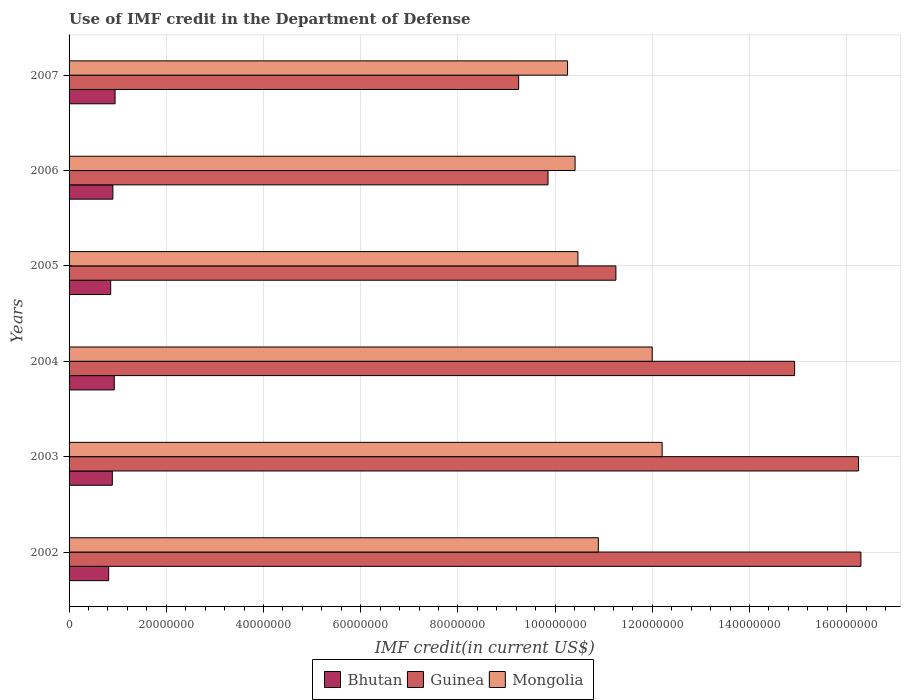How many groups of bars are there?
Ensure brevity in your answer.  6. Are the number of bars on each tick of the Y-axis equal?
Your answer should be compact. Yes. How many bars are there on the 4th tick from the bottom?
Your answer should be compact. 3. What is the label of the 5th group of bars from the top?
Provide a short and direct response. 2003. What is the IMF credit in the Department of Defense in Mongolia in 2004?
Provide a succinct answer. 1.20e+08. Across all years, what is the maximum IMF credit in the Department of Defense in Mongolia?
Offer a very short reply. 1.22e+08. Across all years, what is the minimum IMF credit in the Department of Defense in Guinea?
Offer a terse response. 9.25e+07. What is the total IMF credit in the Department of Defense in Guinea in the graph?
Provide a succinct answer. 7.78e+08. What is the difference between the IMF credit in the Department of Defense in Bhutan in 2003 and that in 2005?
Your response must be concise. 3.39e+05. What is the difference between the IMF credit in the Department of Defense in Bhutan in 2006 and the IMF credit in the Department of Defense in Mongolia in 2005?
Provide a succinct answer. -9.57e+07. What is the average IMF credit in the Department of Defense in Mongolia per year?
Ensure brevity in your answer.  1.10e+08. In the year 2004, what is the difference between the IMF credit in the Department of Defense in Guinea and IMF credit in the Department of Defense in Bhutan?
Offer a very short reply. 1.40e+08. In how many years, is the IMF credit in the Department of Defense in Bhutan greater than 124000000 US$?
Your answer should be very brief. 0. What is the ratio of the IMF credit in the Department of Defense in Mongolia in 2003 to that in 2006?
Provide a succinct answer. 1.17. Is the difference between the IMF credit in the Department of Defense in Guinea in 2006 and 2007 greater than the difference between the IMF credit in the Department of Defense in Bhutan in 2006 and 2007?
Provide a short and direct response. Yes. What is the difference between the highest and the second highest IMF credit in the Department of Defense in Bhutan?
Give a very brief answer. 1.63e+05. What is the difference between the highest and the lowest IMF credit in the Department of Defense in Bhutan?
Your answer should be compact. 1.32e+06. Is the sum of the IMF credit in the Department of Defense in Mongolia in 2003 and 2007 greater than the maximum IMF credit in the Department of Defense in Bhutan across all years?
Your response must be concise. Yes. What does the 2nd bar from the top in 2005 represents?
Give a very brief answer. Guinea. What does the 1st bar from the bottom in 2005 represents?
Offer a terse response. Bhutan. How many bars are there?
Give a very brief answer. 18. Are all the bars in the graph horizontal?
Ensure brevity in your answer.  Yes. How many years are there in the graph?
Provide a short and direct response. 6. What is the difference between two consecutive major ticks on the X-axis?
Offer a terse response. 2.00e+07. Does the graph contain any zero values?
Give a very brief answer. No. Where does the legend appear in the graph?
Offer a terse response. Bottom center. How are the legend labels stacked?
Provide a succinct answer. Horizontal. What is the title of the graph?
Ensure brevity in your answer.  Use of IMF credit in the Department of Defense. Does "Sweden" appear as one of the legend labels in the graph?
Keep it short and to the point. No. What is the label or title of the X-axis?
Make the answer very short. IMF credit(in current US$). What is the IMF credit(in current US$) in Bhutan in 2002?
Give a very brief answer. 8.14e+06. What is the IMF credit(in current US$) of Guinea in 2002?
Provide a succinct answer. 1.63e+08. What is the IMF credit(in current US$) in Mongolia in 2002?
Your answer should be compact. 1.09e+08. What is the IMF credit(in current US$) in Bhutan in 2003?
Provide a succinct answer. 8.90e+06. What is the IMF credit(in current US$) of Guinea in 2003?
Make the answer very short. 1.62e+08. What is the IMF credit(in current US$) of Mongolia in 2003?
Offer a very short reply. 1.22e+08. What is the IMF credit(in current US$) in Bhutan in 2004?
Offer a terse response. 9.30e+06. What is the IMF credit(in current US$) in Guinea in 2004?
Your answer should be very brief. 1.49e+08. What is the IMF credit(in current US$) of Mongolia in 2004?
Offer a very short reply. 1.20e+08. What is the IMF credit(in current US$) of Bhutan in 2005?
Offer a very short reply. 8.56e+06. What is the IMF credit(in current US$) in Guinea in 2005?
Offer a very short reply. 1.13e+08. What is the IMF credit(in current US$) in Mongolia in 2005?
Offer a very short reply. 1.05e+08. What is the IMF credit(in current US$) of Bhutan in 2006?
Your answer should be very brief. 9.01e+06. What is the IMF credit(in current US$) of Guinea in 2006?
Your response must be concise. 9.85e+07. What is the IMF credit(in current US$) of Mongolia in 2006?
Ensure brevity in your answer.  1.04e+08. What is the IMF credit(in current US$) in Bhutan in 2007?
Your answer should be very brief. 9.46e+06. What is the IMF credit(in current US$) of Guinea in 2007?
Ensure brevity in your answer.  9.25e+07. What is the IMF credit(in current US$) of Mongolia in 2007?
Provide a succinct answer. 1.03e+08. Across all years, what is the maximum IMF credit(in current US$) in Bhutan?
Offer a very short reply. 9.46e+06. Across all years, what is the maximum IMF credit(in current US$) in Guinea?
Provide a short and direct response. 1.63e+08. Across all years, what is the maximum IMF credit(in current US$) of Mongolia?
Your answer should be very brief. 1.22e+08. Across all years, what is the minimum IMF credit(in current US$) of Bhutan?
Make the answer very short. 8.14e+06. Across all years, what is the minimum IMF credit(in current US$) of Guinea?
Provide a succinct answer. 9.25e+07. Across all years, what is the minimum IMF credit(in current US$) of Mongolia?
Give a very brief answer. 1.03e+08. What is the total IMF credit(in current US$) in Bhutan in the graph?
Provide a short and direct response. 5.34e+07. What is the total IMF credit(in current US$) of Guinea in the graph?
Give a very brief answer. 7.78e+08. What is the total IMF credit(in current US$) of Mongolia in the graph?
Your answer should be compact. 6.62e+08. What is the difference between the IMF credit(in current US$) of Bhutan in 2002 and that in 2003?
Your answer should be very brief. -7.57e+05. What is the difference between the IMF credit(in current US$) in Guinea in 2002 and that in 2003?
Make the answer very short. 4.97e+05. What is the difference between the IMF credit(in current US$) of Mongolia in 2002 and that in 2003?
Offer a terse response. -1.31e+07. What is the difference between the IMF credit(in current US$) in Bhutan in 2002 and that in 2004?
Provide a short and direct response. -1.16e+06. What is the difference between the IMF credit(in current US$) of Guinea in 2002 and that in 2004?
Provide a succinct answer. 1.36e+07. What is the difference between the IMF credit(in current US$) in Mongolia in 2002 and that in 2004?
Your answer should be very brief. -1.11e+07. What is the difference between the IMF credit(in current US$) of Bhutan in 2002 and that in 2005?
Ensure brevity in your answer.  -4.18e+05. What is the difference between the IMF credit(in current US$) in Guinea in 2002 and that in 2005?
Keep it short and to the point. 5.04e+07. What is the difference between the IMF credit(in current US$) in Mongolia in 2002 and that in 2005?
Your answer should be very brief. 4.20e+06. What is the difference between the IMF credit(in current US$) in Bhutan in 2002 and that in 2006?
Make the answer very short. -8.68e+05. What is the difference between the IMF credit(in current US$) of Guinea in 2002 and that in 2006?
Provide a succinct answer. 6.44e+07. What is the difference between the IMF credit(in current US$) of Mongolia in 2002 and that in 2006?
Your answer should be compact. 4.78e+06. What is the difference between the IMF credit(in current US$) of Bhutan in 2002 and that in 2007?
Your answer should be very brief. -1.32e+06. What is the difference between the IMF credit(in current US$) of Guinea in 2002 and that in 2007?
Your answer should be very brief. 7.04e+07. What is the difference between the IMF credit(in current US$) in Mongolia in 2002 and that in 2007?
Offer a terse response. 6.33e+06. What is the difference between the IMF credit(in current US$) in Bhutan in 2003 and that in 2004?
Provide a succinct answer. -4.02e+05. What is the difference between the IMF credit(in current US$) of Guinea in 2003 and that in 2004?
Make the answer very short. 1.31e+07. What is the difference between the IMF credit(in current US$) in Mongolia in 2003 and that in 2004?
Ensure brevity in your answer.  2.04e+06. What is the difference between the IMF credit(in current US$) of Bhutan in 2003 and that in 2005?
Provide a short and direct response. 3.39e+05. What is the difference between the IMF credit(in current US$) of Guinea in 2003 and that in 2005?
Give a very brief answer. 4.99e+07. What is the difference between the IMF credit(in current US$) of Mongolia in 2003 and that in 2005?
Provide a short and direct response. 1.73e+07. What is the difference between the IMF credit(in current US$) in Bhutan in 2003 and that in 2006?
Make the answer very short. -1.11e+05. What is the difference between the IMF credit(in current US$) in Guinea in 2003 and that in 2006?
Offer a very short reply. 6.39e+07. What is the difference between the IMF credit(in current US$) of Mongolia in 2003 and that in 2006?
Provide a succinct answer. 1.79e+07. What is the difference between the IMF credit(in current US$) of Bhutan in 2003 and that in 2007?
Your answer should be compact. -5.65e+05. What is the difference between the IMF credit(in current US$) of Guinea in 2003 and that in 2007?
Offer a very short reply. 6.99e+07. What is the difference between the IMF credit(in current US$) of Mongolia in 2003 and that in 2007?
Your answer should be very brief. 1.95e+07. What is the difference between the IMF credit(in current US$) in Bhutan in 2004 and that in 2005?
Give a very brief answer. 7.41e+05. What is the difference between the IMF credit(in current US$) in Guinea in 2004 and that in 2005?
Offer a very short reply. 3.68e+07. What is the difference between the IMF credit(in current US$) of Mongolia in 2004 and that in 2005?
Your answer should be very brief. 1.53e+07. What is the difference between the IMF credit(in current US$) in Bhutan in 2004 and that in 2006?
Your response must be concise. 2.91e+05. What is the difference between the IMF credit(in current US$) in Guinea in 2004 and that in 2006?
Provide a succinct answer. 5.07e+07. What is the difference between the IMF credit(in current US$) of Mongolia in 2004 and that in 2006?
Make the answer very short. 1.59e+07. What is the difference between the IMF credit(in current US$) in Bhutan in 2004 and that in 2007?
Offer a very short reply. -1.63e+05. What is the difference between the IMF credit(in current US$) in Guinea in 2004 and that in 2007?
Your response must be concise. 5.68e+07. What is the difference between the IMF credit(in current US$) of Mongolia in 2004 and that in 2007?
Make the answer very short. 1.74e+07. What is the difference between the IMF credit(in current US$) of Bhutan in 2005 and that in 2006?
Ensure brevity in your answer.  -4.50e+05. What is the difference between the IMF credit(in current US$) of Guinea in 2005 and that in 2006?
Keep it short and to the point. 1.40e+07. What is the difference between the IMF credit(in current US$) of Mongolia in 2005 and that in 2006?
Give a very brief answer. 5.81e+05. What is the difference between the IMF credit(in current US$) in Bhutan in 2005 and that in 2007?
Your response must be concise. -9.04e+05. What is the difference between the IMF credit(in current US$) of Guinea in 2005 and that in 2007?
Your answer should be very brief. 2.00e+07. What is the difference between the IMF credit(in current US$) of Mongolia in 2005 and that in 2007?
Provide a succinct answer. 2.13e+06. What is the difference between the IMF credit(in current US$) of Bhutan in 2006 and that in 2007?
Keep it short and to the point. -4.54e+05. What is the difference between the IMF credit(in current US$) in Guinea in 2006 and that in 2007?
Keep it short and to the point. 6.04e+06. What is the difference between the IMF credit(in current US$) in Mongolia in 2006 and that in 2007?
Make the answer very short. 1.55e+06. What is the difference between the IMF credit(in current US$) in Bhutan in 2002 and the IMF credit(in current US$) in Guinea in 2003?
Offer a very short reply. -1.54e+08. What is the difference between the IMF credit(in current US$) in Bhutan in 2002 and the IMF credit(in current US$) in Mongolia in 2003?
Your response must be concise. -1.14e+08. What is the difference between the IMF credit(in current US$) in Guinea in 2002 and the IMF credit(in current US$) in Mongolia in 2003?
Make the answer very short. 4.09e+07. What is the difference between the IMF credit(in current US$) in Bhutan in 2002 and the IMF credit(in current US$) in Guinea in 2004?
Your answer should be very brief. -1.41e+08. What is the difference between the IMF credit(in current US$) of Bhutan in 2002 and the IMF credit(in current US$) of Mongolia in 2004?
Offer a terse response. -1.12e+08. What is the difference between the IMF credit(in current US$) in Guinea in 2002 and the IMF credit(in current US$) in Mongolia in 2004?
Give a very brief answer. 4.29e+07. What is the difference between the IMF credit(in current US$) of Bhutan in 2002 and the IMF credit(in current US$) of Guinea in 2005?
Provide a short and direct response. -1.04e+08. What is the difference between the IMF credit(in current US$) of Bhutan in 2002 and the IMF credit(in current US$) of Mongolia in 2005?
Provide a succinct answer. -9.65e+07. What is the difference between the IMF credit(in current US$) in Guinea in 2002 and the IMF credit(in current US$) in Mongolia in 2005?
Provide a succinct answer. 5.82e+07. What is the difference between the IMF credit(in current US$) of Bhutan in 2002 and the IMF credit(in current US$) of Guinea in 2006?
Offer a terse response. -9.04e+07. What is the difference between the IMF credit(in current US$) of Bhutan in 2002 and the IMF credit(in current US$) of Mongolia in 2006?
Keep it short and to the point. -9.60e+07. What is the difference between the IMF credit(in current US$) in Guinea in 2002 and the IMF credit(in current US$) in Mongolia in 2006?
Give a very brief answer. 5.88e+07. What is the difference between the IMF credit(in current US$) in Bhutan in 2002 and the IMF credit(in current US$) in Guinea in 2007?
Make the answer very short. -8.44e+07. What is the difference between the IMF credit(in current US$) in Bhutan in 2002 and the IMF credit(in current US$) in Mongolia in 2007?
Your answer should be compact. -9.44e+07. What is the difference between the IMF credit(in current US$) of Guinea in 2002 and the IMF credit(in current US$) of Mongolia in 2007?
Your answer should be very brief. 6.04e+07. What is the difference between the IMF credit(in current US$) in Bhutan in 2003 and the IMF credit(in current US$) in Guinea in 2004?
Your answer should be very brief. -1.40e+08. What is the difference between the IMF credit(in current US$) of Bhutan in 2003 and the IMF credit(in current US$) of Mongolia in 2004?
Keep it short and to the point. -1.11e+08. What is the difference between the IMF credit(in current US$) of Guinea in 2003 and the IMF credit(in current US$) of Mongolia in 2004?
Your answer should be compact. 4.24e+07. What is the difference between the IMF credit(in current US$) of Bhutan in 2003 and the IMF credit(in current US$) of Guinea in 2005?
Keep it short and to the point. -1.04e+08. What is the difference between the IMF credit(in current US$) of Bhutan in 2003 and the IMF credit(in current US$) of Mongolia in 2005?
Offer a very short reply. -9.58e+07. What is the difference between the IMF credit(in current US$) in Guinea in 2003 and the IMF credit(in current US$) in Mongolia in 2005?
Keep it short and to the point. 5.77e+07. What is the difference between the IMF credit(in current US$) of Bhutan in 2003 and the IMF credit(in current US$) of Guinea in 2006?
Your response must be concise. -8.96e+07. What is the difference between the IMF credit(in current US$) of Bhutan in 2003 and the IMF credit(in current US$) of Mongolia in 2006?
Your answer should be compact. -9.52e+07. What is the difference between the IMF credit(in current US$) in Guinea in 2003 and the IMF credit(in current US$) in Mongolia in 2006?
Provide a succinct answer. 5.83e+07. What is the difference between the IMF credit(in current US$) of Bhutan in 2003 and the IMF credit(in current US$) of Guinea in 2007?
Keep it short and to the point. -8.36e+07. What is the difference between the IMF credit(in current US$) of Bhutan in 2003 and the IMF credit(in current US$) of Mongolia in 2007?
Offer a very short reply. -9.37e+07. What is the difference between the IMF credit(in current US$) of Guinea in 2003 and the IMF credit(in current US$) of Mongolia in 2007?
Ensure brevity in your answer.  5.99e+07. What is the difference between the IMF credit(in current US$) in Bhutan in 2004 and the IMF credit(in current US$) in Guinea in 2005?
Provide a short and direct response. -1.03e+08. What is the difference between the IMF credit(in current US$) of Bhutan in 2004 and the IMF credit(in current US$) of Mongolia in 2005?
Your answer should be very brief. -9.54e+07. What is the difference between the IMF credit(in current US$) in Guinea in 2004 and the IMF credit(in current US$) in Mongolia in 2005?
Offer a very short reply. 4.46e+07. What is the difference between the IMF credit(in current US$) in Bhutan in 2004 and the IMF credit(in current US$) in Guinea in 2006?
Ensure brevity in your answer.  -8.92e+07. What is the difference between the IMF credit(in current US$) in Bhutan in 2004 and the IMF credit(in current US$) in Mongolia in 2006?
Your response must be concise. -9.48e+07. What is the difference between the IMF credit(in current US$) in Guinea in 2004 and the IMF credit(in current US$) in Mongolia in 2006?
Make the answer very short. 4.52e+07. What is the difference between the IMF credit(in current US$) in Bhutan in 2004 and the IMF credit(in current US$) in Guinea in 2007?
Provide a short and direct response. -8.32e+07. What is the difference between the IMF credit(in current US$) in Bhutan in 2004 and the IMF credit(in current US$) in Mongolia in 2007?
Keep it short and to the point. -9.33e+07. What is the difference between the IMF credit(in current US$) of Guinea in 2004 and the IMF credit(in current US$) of Mongolia in 2007?
Offer a terse response. 4.67e+07. What is the difference between the IMF credit(in current US$) in Bhutan in 2005 and the IMF credit(in current US$) in Guinea in 2006?
Make the answer very short. -9.00e+07. What is the difference between the IMF credit(in current US$) of Bhutan in 2005 and the IMF credit(in current US$) of Mongolia in 2006?
Ensure brevity in your answer.  -9.55e+07. What is the difference between the IMF credit(in current US$) of Guinea in 2005 and the IMF credit(in current US$) of Mongolia in 2006?
Give a very brief answer. 8.40e+06. What is the difference between the IMF credit(in current US$) of Bhutan in 2005 and the IMF credit(in current US$) of Guinea in 2007?
Keep it short and to the point. -8.39e+07. What is the difference between the IMF credit(in current US$) in Bhutan in 2005 and the IMF credit(in current US$) in Mongolia in 2007?
Your answer should be very brief. -9.40e+07. What is the difference between the IMF credit(in current US$) of Guinea in 2005 and the IMF credit(in current US$) of Mongolia in 2007?
Offer a very short reply. 9.94e+06. What is the difference between the IMF credit(in current US$) in Bhutan in 2006 and the IMF credit(in current US$) in Guinea in 2007?
Your answer should be compact. -8.35e+07. What is the difference between the IMF credit(in current US$) in Bhutan in 2006 and the IMF credit(in current US$) in Mongolia in 2007?
Give a very brief answer. -9.36e+07. What is the difference between the IMF credit(in current US$) of Guinea in 2006 and the IMF credit(in current US$) of Mongolia in 2007?
Your response must be concise. -4.02e+06. What is the average IMF credit(in current US$) in Bhutan per year?
Your response must be concise. 8.90e+06. What is the average IMF credit(in current US$) in Guinea per year?
Provide a short and direct response. 1.30e+08. What is the average IMF credit(in current US$) of Mongolia per year?
Your answer should be very brief. 1.10e+08. In the year 2002, what is the difference between the IMF credit(in current US$) of Bhutan and IMF credit(in current US$) of Guinea?
Offer a very short reply. -1.55e+08. In the year 2002, what is the difference between the IMF credit(in current US$) of Bhutan and IMF credit(in current US$) of Mongolia?
Give a very brief answer. -1.01e+08. In the year 2002, what is the difference between the IMF credit(in current US$) of Guinea and IMF credit(in current US$) of Mongolia?
Provide a short and direct response. 5.40e+07. In the year 2003, what is the difference between the IMF credit(in current US$) of Bhutan and IMF credit(in current US$) of Guinea?
Your answer should be compact. -1.54e+08. In the year 2003, what is the difference between the IMF credit(in current US$) of Bhutan and IMF credit(in current US$) of Mongolia?
Offer a very short reply. -1.13e+08. In the year 2003, what is the difference between the IMF credit(in current US$) in Guinea and IMF credit(in current US$) in Mongolia?
Your answer should be very brief. 4.04e+07. In the year 2004, what is the difference between the IMF credit(in current US$) of Bhutan and IMF credit(in current US$) of Guinea?
Offer a very short reply. -1.40e+08. In the year 2004, what is the difference between the IMF credit(in current US$) in Bhutan and IMF credit(in current US$) in Mongolia?
Offer a terse response. -1.11e+08. In the year 2004, what is the difference between the IMF credit(in current US$) in Guinea and IMF credit(in current US$) in Mongolia?
Your answer should be very brief. 2.93e+07. In the year 2005, what is the difference between the IMF credit(in current US$) of Bhutan and IMF credit(in current US$) of Guinea?
Provide a short and direct response. -1.04e+08. In the year 2005, what is the difference between the IMF credit(in current US$) of Bhutan and IMF credit(in current US$) of Mongolia?
Make the answer very short. -9.61e+07. In the year 2005, what is the difference between the IMF credit(in current US$) in Guinea and IMF credit(in current US$) in Mongolia?
Your response must be concise. 7.81e+06. In the year 2006, what is the difference between the IMF credit(in current US$) of Bhutan and IMF credit(in current US$) of Guinea?
Provide a short and direct response. -8.95e+07. In the year 2006, what is the difference between the IMF credit(in current US$) in Bhutan and IMF credit(in current US$) in Mongolia?
Your answer should be compact. -9.51e+07. In the year 2006, what is the difference between the IMF credit(in current US$) of Guinea and IMF credit(in current US$) of Mongolia?
Ensure brevity in your answer.  -5.56e+06. In the year 2007, what is the difference between the IMF credit(in current US$) in Bhutan and IMF credit(in current US$) in Guinea?
Your answer should be very brief. -8.30e+07. In the year 2007, what is the difference between the IMF credit(in current US$) of Bhutan and IMF credit(in current US$) of Mongolia?
Your response must be concise. -9.31e+07. In the year 2007, what is the difference between the IMF credit(in current US$) in Guinea and IMF credit(in current US$) in Mongolia?
Ensure brevity in your answer.  -1.01e+07. What is the ratio of the IMF credit(in current US$) in Bhutan in 2002 to that in 2003?
Make the answer very short. 0.91. What is the ratio of the IMF credit(in current US$) of Guinea in 2002 to that in 2003?
Your response must be concise. 1. What is the ratio of the IMF credit(in current US$) in Mongolia in 2002 to that in 2003?
Make the answer very short. 0.89. What is the ratio of the IMF credit(in current US$) of Bhutan in 2002 to that in 2004?
Keep it short and to the point. 0.88. What is the ratio of the IMF credit(in current US$) of Guinea in 2002 to that in 2004?
Make the answer very short. 1.09. What is the ratio of the IMF credit(in current US$) of Mongolia in 2002 to that in 2004?
Keep it short and to the point. 0.91. What is the ratio of the IMF credit(in current US$) in Bhutan in 2002 to that in 2005?
Your answer should be very brief. 0.95. What is the ratio of the IMF credit(in current US$) of Guinea in 2002 to that in 2005?
Your answer should be very brief. 1.45. What is the ratio of the IMF credit(in current US$) in Mongolia in 2002 to that in 2005?
Your response must be concise. 1.04. What is the ratio of the IMF credit(in current US$) of Bhutan in 2002 to that in 2006?
Provide a short and direct response. 0.9. What is the ratio of the IMF credit(in current US$) in Guinea in 2002 to that in 2006?
Give a very brief answer. 1.65. What is the ratio of the IMF credit(in current US$) of Mongolia in 2002 to that in 2006?
Your response must be concise. 1.05. What is the ratio of the IMF credit(in current US$) of Bhutan in 2002 to that in 2007?
Your answer should be compact. 0.86. What is the ratio of the IMF credit(in current US$) of Guinea in 2002 to that in 2007?
Your answer should be compact. 1.76. What is the ratio of the IMF credit(in current US$) of Mongolia in 2002 to that in 2007?
Make the answer very short. 1.06. What is the ratio of the IMF credit(in current US$) in Bhutan in 2003 to that in 2004?
Keep it short and to the point. 0.96. What is the ratio of the IMF credit(in current US$) of Guinea in 2003 to that in 2004?
Your response must be concise. 1.09. What is the ratio of the IMF credit(in current US$) in Bhutan in 2003 to that in 2005?
Your answer should be very brief. 1.04. What is the ratio of the IMF credit(in current US$) of Guinea in 2003 to that in 2005?
Keep it short and to the point. 1.44. What is the ratio of the IMF credit(in current US$) of Mongolia in 2003 to that in 2005?
Give a very brief answer. 1.17. What is the ratio of the IMF credit(in current US$) in Guinea in 2003 to that in 2006?
Your answer should be compact. 1.65. What is the ratio of the IMF credit(in current US$) in Mongolia in 2003 to that in 2006?
Your answer should be very brief. 1.17. What is the ratio of the IMF credit(in current US$) of Bhutan in 2003 to that in 2007?
Keep it short and to the point. 0.94. What is the ratio of the IMF credit(in current US$) in Guinea in 2003 to that in 2007?
Provide a short and direct response. 1.76. What is the ratio of the IMF credit(in current US$) of Mongolia in 2003 to that in 2007?
Offer a terse response. 1.19. What is the ratio of the IMF credit(in current US$) of Bhutan in 2004 to that in 2005?
Offer a very short reply. 1.09. What is the ratio of the IMF credit(in current US$) in Guinea in 2004 to that in 2005?
Ensure brevity in your answer.  1.33. What is the ratio of the IMF credit(in current US$) in Mongolia in 2004 to that in 2005?
Provide a succinct answer. 1.15. What is the ratio of the IMF credit(in current US$) of Bhutan in 2004 to that in 2006?
Provide a succinct answer. 1.03. What is the ratio of the IMF credit(in current US$) of Guinea in 2004 to that in 2006?
Give a very brief answer. 1.51. What is the ratio of the IMF credit(in current US$) in Mongolia in 2004 to that in 2006?
Offer a terse response. 1.15. What is the ratio of the IMF credit(in current US$) of Bhutan in 2004 to that in 2007?
Provide a short and direct response. 0.98. What is the ratio of the IMF credit(in current US$) in Guinea in 2004 to that in 2007?
Your answer should be very brief. 1.61. What is the ratio of the IMF credit(in current US$) of Mongolia in 2004 to that in 2007?
Keep it short and to the point. 1.17. What is the ratio of the IMF credit(in current US$) in Bhutan in 2005 to that in 2006?
Offer a very short reply. 0.95. What is the ratio of the IMF credit(in current US$) in Guinea in 2005 to that in 2006?
Keep it short and to the point. 1.14. What is the ratio of the IMF credit(in current US$) of Mongolia in 2005 to that in 2006?
Make the answer very short. 1.01. What is the ratio of the IMF credit(in current US$) of Bhutan in 2005 to that in 2007?
Offer a very short reply. 0.9. What is the ratio of the IMF credit(in current US$) of Guinea in 2005 to that in 2007?
Offer a very short reply. 1.22. What is the ratio of the IMF credit(in current US$) in Mongolia in 2005 to that in 2007?
Make the answer very short. 1.02. What is the ratio of the IMF credit(in current US$) of Guinea in 2006 to that in 2007?
Keep it short and to the point. 1.07. What is the ratio of the IMF credit(in current US$) of Mongolia in 2006 to that in 2007?
Offer a very short reply. 1.02. What is the difference between the highest and the second highest IMF credit(in current US$) of Bhutan?
Keep it short and to the point. 1.63e+05. What is the difference between the highest and the second highest IMF credit(in current US$) in Guinea?
Offer a very short reply. 4.97e+05. What is the difference between the highest and the second highest IMF credit(in current US$) in Mongolia?
Your response must be concise. 2.04e+06. What is the difference between the highest and the lowest IMF credit(in current US$) in Bhutan?
Your answer should be very brief. 1.32e+06. What is the difference between the highest and the lowest IMF credit(in current US$) of Guinea?
Provide a succinct answer. 7.04e+07. What is the difference between the highest and the lowest IMF credit(in current US$) of Mongolia?
Your answer should be very brief. 1.95e+07. 